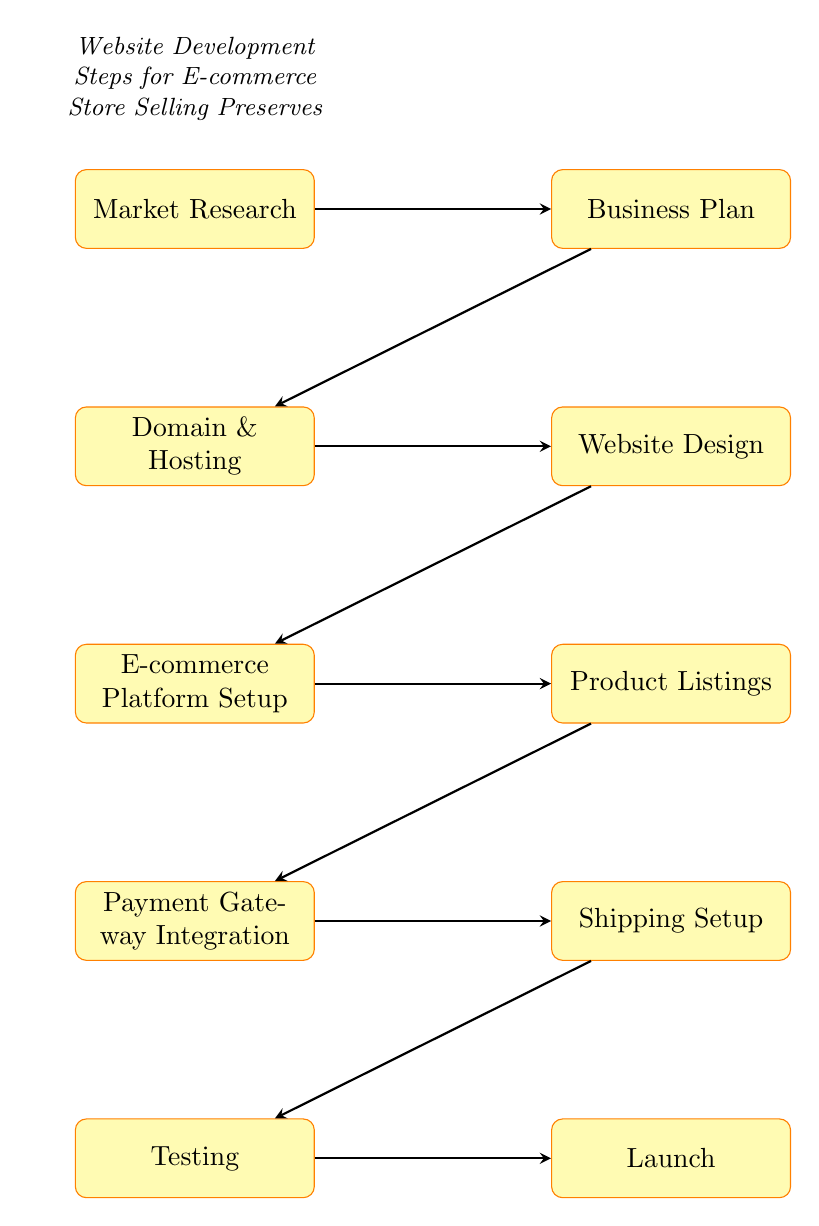What is the first step in website development? The first step depicted in the diagram is labeled "Market Research," which is the initial process before moving on to further steps.
Answer: Market Research How many total steps are there in the flow chart? By counting each node in the diagram, from "Market Research" to "Launch," there are ten nodes, which represent steps in the development process.
Answer: 10 What comes after "Domain & Hosting"? According to the flow structure, the step that follows "Domain & Hosting" is "Website Design," indicating the next phase in the development after securing a domain and hosting.
Answer: Website Design Is "Testing" a step that occurs before or after "Payment Gateway Integration"? By evaluating the flow of the diagram, "Testing" occurs after "Payment Gateway Integration," suggesting it tests the features that were integrated earlier.
Answer: After Which two steps are connected directly by an arrow? The connections between adjacent nodes are represented by arrows; for instance, "Shipping Setup" is directly connected to "Testing," showing a sequential relationship.
Answer: Shipping Setup and Testing What type of platform can be set up in step five? The diagram specifies in "E-commerce Platform Setup" that options include platforms such as Shopify or WooCommerce, which are common for setting up e-commerce capabilities.
Answer: Shopify, WooCommerce What is the last step in the development process? The final node in the flow chart points to "Launch," marking the end of the development sequence when the website goes live.
Answer: Launch How many steps are there between "Business Plan" and "Product Listings"? Counting the steps in order, there are four steps between "Business Plan" and "Product Listings," which are "Domain & Hosting," "Website Design," and "E-commerce Platform Setup."
Answer: 4 Which step involves arranging shipping options? "Shipping Setup" is the dedicated step that deals with the organization of available shipping options and associated rates, according to the flow of the diagram.
Answer: Shipping Setup Which step describes purchasing a domain name? The step "Domain & Hosting" is specifically about purchasing a domain name, indicating a preparatory action for the website development.
Answer: Domain & Hosting 